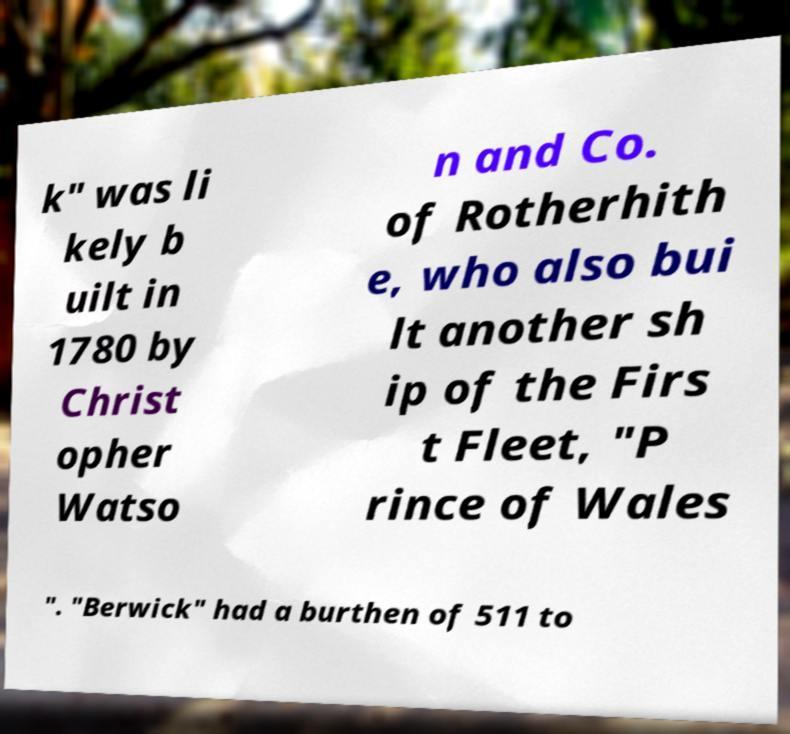Can you read and provide the text displayed in the image?This photo seems to have some interesting text. Can you extract and type it out for me? k" was li kely b uilt in 1780 by Christ opher Watso n and Co. of Rotherhith e, who also bui lt another sh ip of the Firs t Fleet, "P rince of Wales ". "Berwick" had a burthen of 511 to 